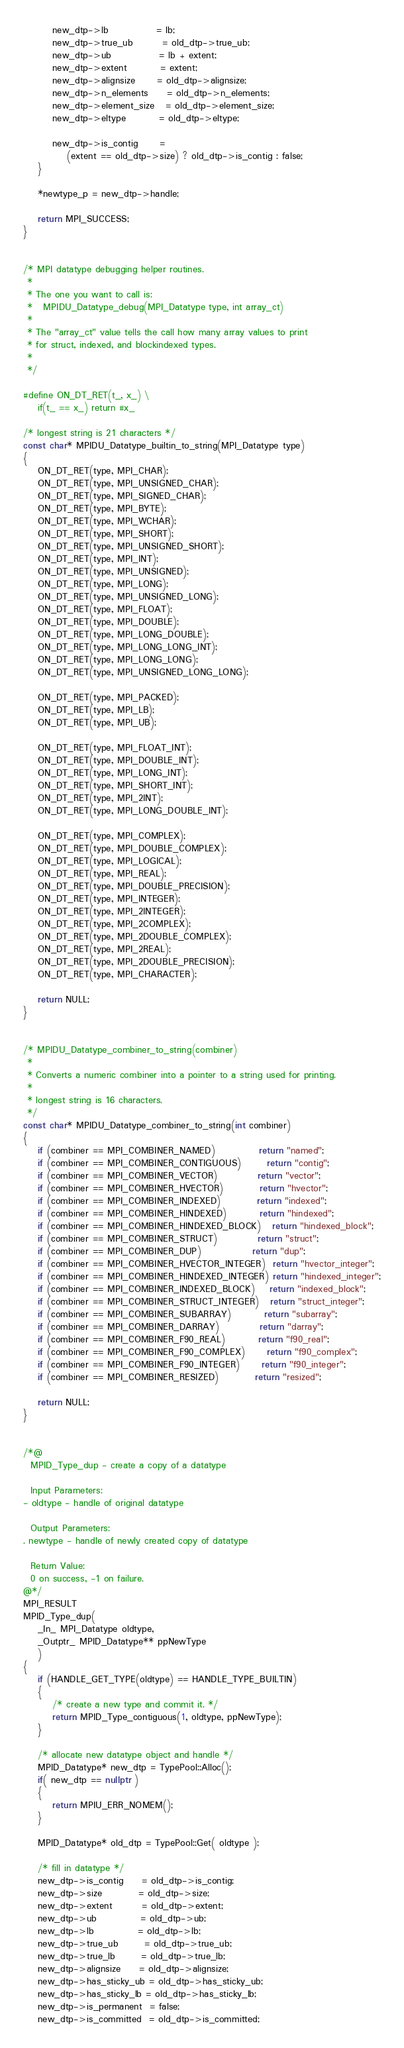Convert code to text. <code><loc_0><loc_0><loc_500><loc_500><_C++_>        new_dtp->lb             = lb;
        new_dtp->true_ub        = old_dtp->true_ub;
        new_dtp->ub             = lb + extent;
        new_dtp->extent         = extent;
        new_dtp->alignsize      = old_dtp->alignsize;
        new_dtp->n_elements     = old_dtp->n_elements;
        new_dtp->element_size   = old_dtp->element_size;
        new_dtp->eltype         = old_dtp->eltype;

        new_dtp->is_contig      =
            (extent == old_dtp->size) ? old_dtp->is_contig : false;
    }

    *newtype_p = new_dtp->handle;

    return MPI_SUCCESS;
}


/* MPI datatype debugging helper routines.
 *
 * The one you want to call is:
 *   MPIDU_Datatype_debug(MPI_Datatype type, int array_ct)
 *
 * The "array_ct" value tells the call how many array values to print
 * for struct, indexed, and blockindexed types.
 *
 */

#define ON_DT_RET(t_, x_) \
    if(t_ == x_) return #x_

/* longest string is 21 characters */
const char* MPIDU_Datatype_builtin_to_string(MPI_Datatype type)
{
    ON_DT_RET(type, MPI_CHAR);
    ON_DT_RET(type, MPI_UNSIGNED_CHAR);
    ON_DT_RET(type, MPI_SIGNED_CHAR);
    ON_DT_RET(type, MPI_BYTE);
    ON_DT_RET(type, MPI_WCHAR);
    ON_DT_RET(type, MPI_SHORT);
    ON_DT_RET(type, MPI_UNSIGNED_SHORT);
    ON_DT_RET(type, MPI_INT);
    ON_DT_RET(type, MPI_UNSIGNED);
    ON_DT_RET(type, MPI_LONG);
    ON_DT_RET(type, MPI_UNSIGNED_LONG);
    ON_DT_RET(type, MPI_FLOAT);
    ON_DT_RET(type, MPI_DOUBLE);
    ON_DT_RET(type, MPI_LONG_DOUBLE);
    ON_DT_RET(type, MPI_LONG_LONG_INT);
    ON_DT_RET(type, MPI_LONG_LONG);
    ON_DT_RET(type, MPI_UNSIGNED_LONG_LONG);

    ON_DT_RET(type, MPI_PACKED);
    ON_DT_RET(type, MPI_LB);
    ON_DT_RET(type, MPI_UB);

    ON_DT_RET(type, MPI_FLOAT_INT);
    ON_DT_RET(type, MPI_DOUBLE_INT);
    ON_DT_RET(type, MPI_LONG_INT);
    ON_DT_RET(type, MPI_SHORT_INT);
    ON_DT_RET(type, MPI_2INT);
    ON_DT_RET(type, MPI_LONG_DOUBLE_INT);

    ON_DT_RET(type, MPI_COMPLEX);
    ON_DT_RET(type, MPI_DOUBLE_COMPLEX);
    ON_DT_RET(type, MPI_LOGICAL);
    ON_DT_RET(type, MPI_REAL);
    ON_DT_RET(type, MPI_DOUBLE_PRECISION);
    ON_DT_RET(type, MPI_INTEGER);
    ON_DT_RET(type, MPI_2INTEGER);
    ON_DT_RET(type, MPI_2COMPLEX);
    ON_DT_RET(type, MPI_2DOUBLE_COMPLEX);
    ON_DT_RET(type, MPI_2REAL);
    ON_DT_RET(type, MPI_2DOUBLE_PRECISION);
    ON_DT_RET(type, MPI_CHARACTER);

    return NULL;
}


/* MPIDU_Datatype_combiner_to_string(combiner)
 *
 * Converts a numeric combiner into a pointer to a string used for printing.
 *
 * longest string is 16 characters.
 */
const char* MPIDU_Datatype_combiner_to_string(int combiner)
{
    if (combiner == MPI_COMBINER_NAMED)            return "named";
    if (combiner == MPI_COMBINER_CONTIGUOUS)       return "contig";
    if (combiner == MPI_COMBINER_VECTOR)           return "vector";
    if (combiner == MPI_COMBINER_HVECTOR)          return "hvector";
    if (combiner == MPI_COMBINER_INDEXED)          return "indexed";
    if (combiner == MPI_COMBINER_HINDEXED)         return "hindexed";
    if (combiner == MPI_COMBINER_HINDEXED_BLOCK)   return "hindexed_block";
    if (combiner == MPI_COMBINER_STRUCT)           return "struct";
    if (combiner == MPI_COMBINER_DUP)              return "dup";
    if (combiner == MPI_COMBINER_HVECTOR_INTEGER)  return "hvector_integer";
    if (combiner == MPI_COMBINER_HINDEXED_INTEGER) return "hindexed_integer";
    if (combiner == MPI_COMBINER_INDEXED_BLOCK)    return "indexed_block";
    if (combiner == MPI_COMBINER_STRUCT_INTEGER)   return "struct_integer";
    if (combiner == MPI_COMBINER_SUBARRAY)         return "subarray";
    if (combiner == MPI_COMBINER_DARRAY)           return "darray";
    if (combiner == MPI_COMBINER_F90_REAL)         return "f90_real";
    if (combiner == MPI_COMBINER_F90_COMPLEX)      return "f90_complex";
    if (combiner == MPI_COMBINER_F90_INTEGER)      return "f90_integer";
    if (combiner == MPI_COMBINER_RESIZED)          return "resized";

    return NULL;
}


/*@
  MPID_Type_dup - create a copy of a datatype

  Input Parameters:
- oldtype - handle of original datatype

  Output Parameters:
. newtype - handle of newly created copy of datatype

  Return Value:
  0 on success, -1 on failure.
@*/
MPI_RESULT
MPID_Type_dup(
    _In_ MPI_Datatype oldtype,
    _Outptr_ MPID_Datatype** ppNewType
    )
{
    if (HANDLE_GET_TYPE(oldtype) == HANDLE_TYPE_BUILTIN)
    {
        /* create a new type and commit it. */
        return MPID_Type_contiguous(1, oldtype, ppNewType);
    }

    /* allocate new datatype object and handle */
    MPID_Datatype* new_dtp = TypePool::Alloc();
    if( new_dtp == nullptr )
    {
        return MPIU_ERR_NOMEM();
    }

    MPID_Datatype* old_dtp = TypePool::Get( oldtype );

    /* fill in datatype */
    new_dtp->is_contig     = old_dtp->is_contig;
    new_dtp->size          = old_dtp->size;
    new_dtp->extent        = old_dtp->extent;
    new_dtp->ub            = old_dtp->ub;
    new_dtp->lb            = old_dtp->lb;
    new_dtp->true_ub       = old_dtp->true_ub;
    new_dtp->true_lb       = old_dtp->true_lb;
    new_dtp->alignsize     = old_dtp->alignsize;
    new_dtp->has_sticky_ub = old_dtp->has_sticky_ub;
    new_dtp->has_sticky_lb = old_dtp->has_sticky_lb;
    new_dtp->is_permanent  = false;
    new_dtp->is_committed  = old_dtp->is_committed;</code> 